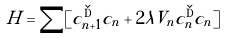<formula> <loc_0><loc_0><loc_500><loc_500>H = \sum [ c _ { n + 1 } ^ { \dag } c _ { n } + 2 \lambda V _ { n } c ^ { \dag } _ { n } c _ { n } ]</formula> 